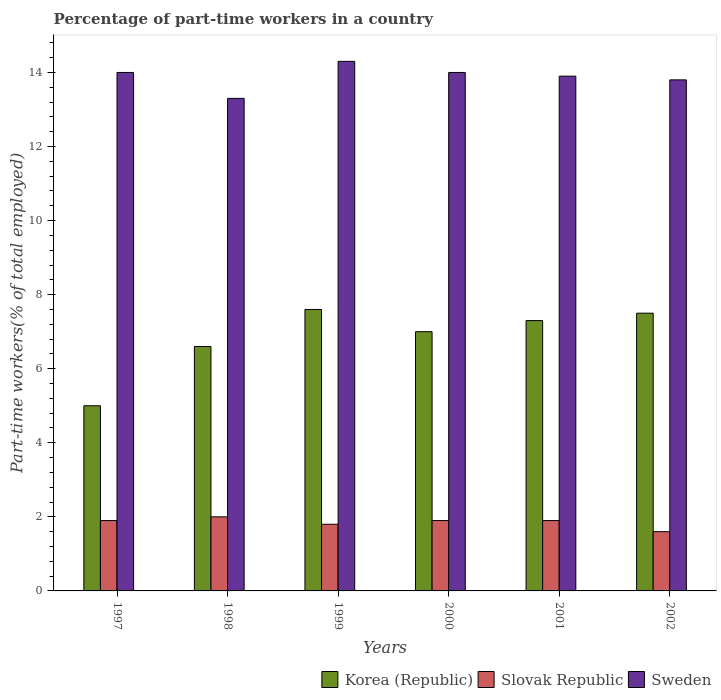How many bars are there on the 2nd tick from the left?
Offer a terse response. 3. What is the label of the 5th group of bars from the left?
Provide a short and direct response. 2001. In how many cases, is the number of bars for a given year not equal to the number of legend labels?
Make the answer very short. 0. What is the percentage of part-time workers in Sweden in 2000?
Provide a short and direct response. 14. Across all years, what is the maximum percentage of part-time workers in Sweden?
Provide a succinct answer. 14.3. Across all years, what is the minimum percentage of part-time workers in Slovak Republic?
Your answer should be very brief. 1.6. What is the total percentage of part-time workers in Sweden in the graph?
Keep it short and to the point. 83.3. What is the difference between the percentage of part-time workers in Korea (Republic) in 2001 and that in 2002?
Your response must be concise. -0.2. What is the average percentage of part-time workers in Sweden per year?
Make the answer very short. 13.88. In the year 2000, what is the difference between the percentage of part-time workers in Slovak Republic and percentage of part-time workers in Sweden?
Your answer should be compact. -12.1. In how many years, is the percentage of part-time workers in Slovak Republic greater than 3.2 %?
Make the answer very short. 0. What is the ratio of the percentage of part-time workers in Korea (Republic) in 1997 to that in 1999?
Offer a very short reply. 0.66. Is the percentage of part-time workers in Korea (Republic) in 1999 less than that in 2001?
Provide a short and direct response. No. Is the difference between the percentage of part-time workers in Slovak Republic in 1997 and 1999 greater than the difference between the percentage of part-time workers in Sweden in 1997 and 1999?
Offer a very short reply. Yes. What is the difference between the highest and the second highest percentage of part-time workers in Slovak Republic?
Your answer should be compact. 0.1. Is it the case that in every year, the sum of the percentage of part-time workers in Slovak Republic and percentage of part-time workers in Sweden is greater than the percentage of part-time workers in Korea (Republic)?
Make the answer very short. Yes. How many bars are there?
Provide a short and direct response. 18. Are all the bars in the graph horizontal?
Offer a terse response. No. Are the values on the major ticks of Y-axis written in scientific E-notation?
Make the answer very short. No. Does the graph contain grids?
Your response must be concise. No. What is the title of the graph?
Offer a very short reply. Percentage of part-time workers in a country. Does "Togo" appear as one of the legend labels in the graph?
Your response must be concise. No. What is the label or title of the X-axis?
Your answer should be compact. Years. What is the label or title of the Y-axis?
Ensure brevity in your answer.  Part-time workers(% of total employed). What is the Part-time workers(% of total employed) in Korea (Republic) in 1997?
Ensure brevity in your answer.  5. What is the Part-time workers(% of total employed) in Slovak Republic in 1997?
Your response must be concise. 1.9. What is the Part-time workers(% of total employed) in Sweden in 1997?
Offer a terse response. 14. What is the Part-time workers(% of total employed) of Korea (Republic) in 1998?
Offer a terse response. 6.6. What is the Part-time workers(% of total employed) in Slovak Republic in 1998?
Keep it short and to the point. 2. What is the Part-time workers(% of total employed) in Sweden in 1998?
Your answer should be compact. 13.3. What is the Part-time workers(% of total employed) in Korea (Republic) in 1999?
Make the answer very short. 7.6. What is the Part-time workers(% of total employed) in Slovak Republic in 1999?
Offer a very short reply. 1.8. What is the Part-time workers(% of total employed) of Sweden in 1999?
Your answer should be very brief. 14.3. What is the Part-time workers(% of total employed) of Slovak Republic in 2000?
Your answer should be compact. 1.9. What is the Part-time workers(% of total employed) of Korea (Republic) in 2001?
Offer a terse response. 7.3. What is the Part-time workers(% of total employed) of Slovak Republic in 2001?
Offer a terse response. 1.9. What is the Part-time workers(% of total employed) of Sweden in 2001?
Give a very brief answer. 13.9. What is the Part-time workers(% of total employed) in Korea (Republic) in 2002?
Offer a terse response. 7.5. What is the Part-time workers(% of total employed) in Slovak Republic in 2002?
Your response must be concise. 1.6. What is the Part-time workers(% of total employed) of Sweden in 2002?
Provide a succinct answer. 13.8. Across all years, what is the maximum Part-time workers(% of total employed) in Korea (Republic)?
Ensure brevity in your answer.  7.6. Across all years, what is the maximum Part-time workers(% of total employed) of Sweden?
Your response must be concise. 14.3. Across all years, what is the minimum Part-time workers(% of total employed) in Slovak Republic?
Your response must be concise. 1.6. Across all years, what is the minimum Part-time workers(% of total employed) of Sweden?
Your answer should be compact. 13.3. What is the total Part-time workers(% of total employed) in Korea (Republic) in the graph?
Give a very brief answer. 41. What is the total Part-time workers(% of total employed) of Sweden in the graph?
Your answer should be very brief. 83.3. What is the difference between the Part-time workers(% of total employed) in Korea (Republic) in 1997 and that in 1998?
Make the answer very short. -1.6. What is the difference between the Part-time workers(% of total employed) of Sweden in 1997 and that in 1998?
Offer a very short reply. 0.7. What is the difference between the Part-time workers(% of total employed) of Slovak Republic in 1997 and that in 2001?
Your answer should be compact. 0. What is the difference between the Part-time workers(% of total employed) in Sweden in 1997 and that in 2001?
Provide a short and direct response. 0.1. What is the difference between the Part-time workers(% of total employed) of Korea (Republic) in 1997 and that in 2002?
Your response must be concise. -2.5. What is the difference between the Part-time workers(% of total employed) of Sweden in 1997 and that in 2002?
Make the answer very short. 0.2. What is the difference between the Part-time workers(% of total employed) of Slovak Republic in 1998 and that in 1999?
Offer a very short reply. 0.2. What is the difference between the Part-time workers(% of total employed) of Korea (Republic) in 1998 and that in 2000?
Your answer should be compact. -0.4. What is the difference between the Part-time workers(% of total employed) in Korea (Republic) in 1998 and that in 2002?
Your answer should be very brief. -0.9. What is the difference between the Part-time workers(% of total employed) in Sweden in 1998 and that in 2002?
Keep it short and to the point. -0.5. What is the difference between the Part-time workers(% of total employed) in Korea (Republic) in 1999 and that in 2000?
Your answer should be very brief. 0.6. What is the difference between the Part-time workers(% of total employed) in Slovak Republic in 1999 and that in 2000?
Keep it short and to the point. -0.1. What is the difference between the Part-time workers(% of total employed) in Sweden in 1999 and that in 2000?
Provide a succinct answer. 0.3. What is the difference between the Part-time workers(% of total employed) of Slovak Republic in 1999 and that in 2001?
Provide a short and direct response. -0.1. What is the difference between the Part-time workers(% of total employed) in Sweden in 1999 and that in 2001?
Offer a very short reply. 0.4. What is the difference between the Part-time workers(% of total employed) in Slovak Republic in 1999 and that in 2002?
Offer a terse response. 0.2. What is the difference between the Part-time workers(% of total employed) of Korea (Republic) in 2000 and that in 2001?
Make the answer very short. -0.3. What is the difference between the Part-time workers(% of total employed) of Korea (Republic) in 2001 and that in 2002?
Give a very brief answer. -0.2. What is the difference between the Part-time workers(% of total employed) in Sweden in 2001 and that in 2002?
Your response must be concise. 0.1. What is the difference between the Part-time workers(% of total employed) of Korea (Republic) in 1997 and the Part-time workers(% of total employed) of Slovak Republic in 1998?
Your answer should be compact. 3. What is the difference between the Part-time workers(% of total employed) of Slovak Republic in 1997 and the Part-time workers(% of total employed) of Sweden in 1998?
Give a very brief answer. -11.4. What is the difference between the Part-time workers(% of total employed) of Korea (Republic) in 1997 and the Part-time workers(% of total employed) of Sweden in 1999?
Keep it short and to the point. -9.3. What is the difference between the Part-time workers(% of total employed) in Slovak Republic in 1997 and the Part-time workers(% of total employed) in Sweden in 1999?
Your answer should be very brief. -12.4. What is the difference between the Part-time workers(% of total employed) in Korea (Republic) in 1997 and the Part-time workers(% of total employed) in Slovak Republic in 2000?
Your answer should be very brief. 3.1. What is the difference between the Part-time workers(% of total employed) in Korea (Republic) in 1997 and the Part-time workers(% of total employed) in Sweden in 2000?
Provide a short and direct response. -9. What is the difference between the Part-time workers(% of total employed) in Slovak Republic in 1997 and the Part-time workers(% of total employed) in Sweden in 2002?
Your answer should be compact. -11.9. What is the difference between the Part-time workers(% of total employed) of Korea (Republic) in 1998 and the Part-time workers(% of total employed) of Slovak Republic in 1999?
Your answer should be very brief. 4.8. What is the difference between the Part-time workers(% of total employed) in Korea (Republic) in 1998 and the Part-time workers(% of total employed) in Sweden in 2000?
Your answer should be compact. -7.4. What is the difference between the Part-time workers(% of total employed) of Korea (Republic) in 1998 and the Part-time workers(% of total employed) of Slovak Republic in 2001?
Ensure brevity in your answer.  4.7. What is the difference between the Part-time workers(% of total employed) of Korea (Republic) in 1998 and the Part-time workers(% of total employed) of Sweden in 2001?
Offer a terse response. -7.3. What is the difference between the Part-time workers(% of total employed) of Slovak Republic in 1998 and the Part-time workers(% of total employed) of Sweden in 2002?
Make the answer very short. -11.8. What is the difference between the Part-time workers(% of total employed) in Slovak Republic in 1999 and the Part-time workers(% of total employed) in Sweden in 2000?
Ensure brevity in your answer.  -12.2. What is the difference between the Part-time workers(% of total employed) of Korea (Republic) in 1999 and the Part-time workers(% of total employed) of Slovak Republic in 2001?
Give a very brief answer. 5.7. What is the difference between the Part-time workers(% of total employed) of Korea (Republic) in 1999 and the Part-time workers(% of total employed) of Sweden in 2001?
Your answer should be very brief. -6.3. What is the difference between the Part-time workers(% of total employed) of Korea (Republic) in 1999 and the Part-time workers(% of total employed) of Slovak Republic in 2002?
Provide a succinct answer. 6. What is the difference between the Part-time workers(% of total employed) of Slovak Republic in 1999 and the Part-time workers(% of total employed) of Sweden in 2002?
Your response must be concise. -12. What is the difference between the Part-time workers(% of total employed) in Korea (Republic) in 2000 and the Part-time workers(% of total employed) in Sweden in 2001?
Make the answer very short. -6.9. What is the difference between the Part-time workers(% of total employed) of Korea (Republic) in 2000 and the Part-time workers(% of total employed) of Sweden in 2002?
Provide a succinct answer. -6.8. What is the difference between the Part-time workers(% of total employed) in Slovak Republic in 2000 and the Part-time workers(% of total employed) in Sweden in 2002?
Your answer should be very brief. -11.9. What is the difference between the Part-time workers(% of total employed) of Korea (Republic) in 2001 and the Part-time workers(% of total employed) of Slovak Republic in 2002?
Provide a short and direct response. 5.7. What is the difference between the Part-time workers(% of total employed) in Korea (Republic) in 2001 and the Part-time workers(% of total employed) in Sweden in 2002?
Give a very brief answer. -6.5. What is the difference between the Part-time workers(% of total employed) of Slovak Republic in 2001 and the Part-time workers(% of total employed) of Sweden in 2002?
Your response must be concise. -11.9. What is the average Part-time workers(% of total employed) in Korea (Republic) per year?
Give a very brief answer. 6.83. What is the average Part-time workers(% of total employed) of Slovak Republic per year?
Your answer should be compact. 1.85. What is the average Part-time workers(% of total employed) of Sweden per year?
Your answer should be compact. 13.88. In the year 1997, what is the difference between the Part-time workers(% of total employed) of Korea (Republic) and Part-time workers(% of total employed) of Sweden?
Give a very brief answer. -9. In the year 1997, what is the difference between the Part-time workers(% of total employed) of Slovak Republic and Part-time workers(% of total employed) of Sweden?
Your response must be concise. -12.1. In the year 1998, what is the difference between the Part-time workers(% of total employed) in Korea (Republic) and Part-time workers(% of total employed) in Sweden?
Give a very brief answer. -6.7. In the year 1999, what is the difference between the Part-time workers(% of total employed) in Korea (Republic) and Part-time workers(% of total employed) in Sweden?
Offer a very short reply. -6.7. In the year 2000, what is the difference between the Part-time workers(% of total employed) in Slovak Republic and Part-time workers(% of total employed) in Sweden?
Keep it short and to the point. -12.1. In the year 2001, what is the difference between the Part-time workers(% of total employed) of Korea (Republic) and Part-time workers(% of total employed) of Slovak Republic?
Offer a very short reply. 5.4. In the year 2001, what is the difference between the Part-time workers(% of total employed) of Korea (Republic) and Part-time workers(% of total employed) of Sweden?
Provide a short and direct response. -6.6. In the year 2002, what is the difference between the Part-time workers(% of total employed) of Korea (Republic) and Part-time workers(% of total employed) of Slovak Republic?
Your response must be concise. 5.9. What is the ratio of the Part-time workers(% of total employed) of Korea (Republic) in 1997 to that in 1998?
Provide a short and direct response. 0.76. What is the ratio of the Part-time workers(% of total employed) of Sweden in 1997 to that in 1998?
Your answer should be very brief. 1.05. What is the ratio of the Part-time workers(% of total employed) of Korea (Republic) in 1997 to that in 1999?
Offer a very short reply. 0.66. What is the ratio of the Part-time workers(% of total employed) in Slovak Republic in 1997 to that in 1999?
Keep it short and to the point. 1.06. What is the ratio of the Part-time workers(% of total employed) in Korea (Republic) in 1997 to that in 2000?
Keep it short and to the point. 0.71. What is the ratio of the Part-time workers(% of total employed) of Slovak Republic in 1997 to that in 2000?
Keep it short and to the point. 1. What is the ratio of the Part-time workers(% of total employed) in Sweden in 1997 to that in 2000?
Offer a very short reply. 1. What is the ratio of the Part-time workers(% of total employed) of Korea (Republic) in 1997 to that in 2001?
Your answer should be very brief. 0.68. What is the ratio of the Part-time workers(% of total employed) in Slovak Republic in 1997 to that in 2002?
Give a very brief answer. 1.19. What is the ratio of the Part-time workers(% of total employed) in Sweden in 1997 to that in 2002?
Make the answer very short. 1.01. What is the ratio of the Part-time workers(% of total employed) in Korea (Republic) in 1998 to that in 1999?
Keep it short and to the point. 0.87. What is the ratio of the Part-time workers(% of total employed) in Sweden in 1998 to that in 1999?
Your response must be concise. 0.93. What is the ratio of the Part-time workers(% of total employed) in Korea (Republic) in 1998 to that in 2000?
Offer a very short reply. 0.94. What is the ratio of the Part-time workers(% of total employed) in Slovak Republic in 1998 to that in 2000?
Your answer should be very brief. 1.05. What is the ratio of the Part-time workers(% of total employed) of Sweden in 1998 to that in 2000?
Keep it short and to the point. 0.95. What is the ratio of the Part-time workers(% of total employed) in Korea (Republic) in 1998 to that in 2001?
Provide a short and direct response. 0.9. What is the ratio of the Part-time workers(% of total employed) in Slovak Republic in 1998 to that in 2001?
Your answer should be compact. 1.05. What is the ratio of the Part-time workers(% of total employed) of Sweden in 1998 to that in 2001?
Your answer should be very brief. 0.96. What is the ratio of the Part-time workers(% of total employed) of Korea (Republic) in 1998 to that in 2002?
Offer a very short reply. 0.88. What is the ratio of the Part-time workers(% of total employed) of Sweden in 1998 to that in 2002?
Keep it short and to the point. 0.96. What is the ratio of the Part-time workers(% of total employed) of Korea (Republic) in 1999 to that in 2000?
Ensure brevity in your answer.  1.09. What is the ratio of the Part-time workers(% of total employed) in Sweden in 1999 to that in 2000?
Provide a short and direct response. 1.02. What is the ratio of the Part-time workers(% of total employed) of Korea (Republic) in 1999 to that in 2001?
Give a very brief answer. 1.04. What is the ratio of the Part-time workers(% of total employed) of Slovak Republic in 1999 to that in 2001?
Your answer should be very brief. 0.95. What is the ratio of the Part-time workers(% of total employed) in Sweden in 1999 to that in 2001?
Give a very brief answer. 1.03. What is the ratio of the Part-time workers(% of total employed) in Korea (Republic) in 1999 to that in 2002?
Ensure brevity in your answer.  1.01. What is the ratio of the Part-time workers(% of total employed) of Sweden in 1999 to that in 2002?
Offer a terse response. 1.04. What is the ratio of the Part-time workers(% of total employed) in Korea (Republic) in 2000 to that in 2001?
Provide a short and direct response. 0.96. What is the ratio of the Part-time workers(% of total employed) of Sweden in 2000 to that in 2001?
Your answer should be compact. 1.01. What is the ratio of the Part-time workers(% of total employed) in Slovak Republic in 2000 to that in 2002?
Give a very brief answer. 1.19. What is the ratio of the Part-time workers(% of total employed) of Sweden in 2000 to that in 2002?
Make the answer very short. 1.01. What is the ratio of the Part-time workers(% of total employed) of Korea (Republic) in 2001 to that in 2002?
Make the answer very short. 0.97. What is the ratio of the Part-time workers(% of total employed) of Slovak Republic in 2001 to that in 2002?
Your answer should be compact. 1.19. What is the ratio of the Part-time workers(% of total employed) of Sweden in 2001 to that in 2002?
Provide a succinct answer. 1.01. What is the difference between the highest and the second highest Part-time workers(% of total employed) of Slovak Republic?
Your answer should be compact. 0.1. What is the difference between the highest and the second highest Part-time workers(% of total employed) of Sweden?
Offer a terse response. 0.3. 